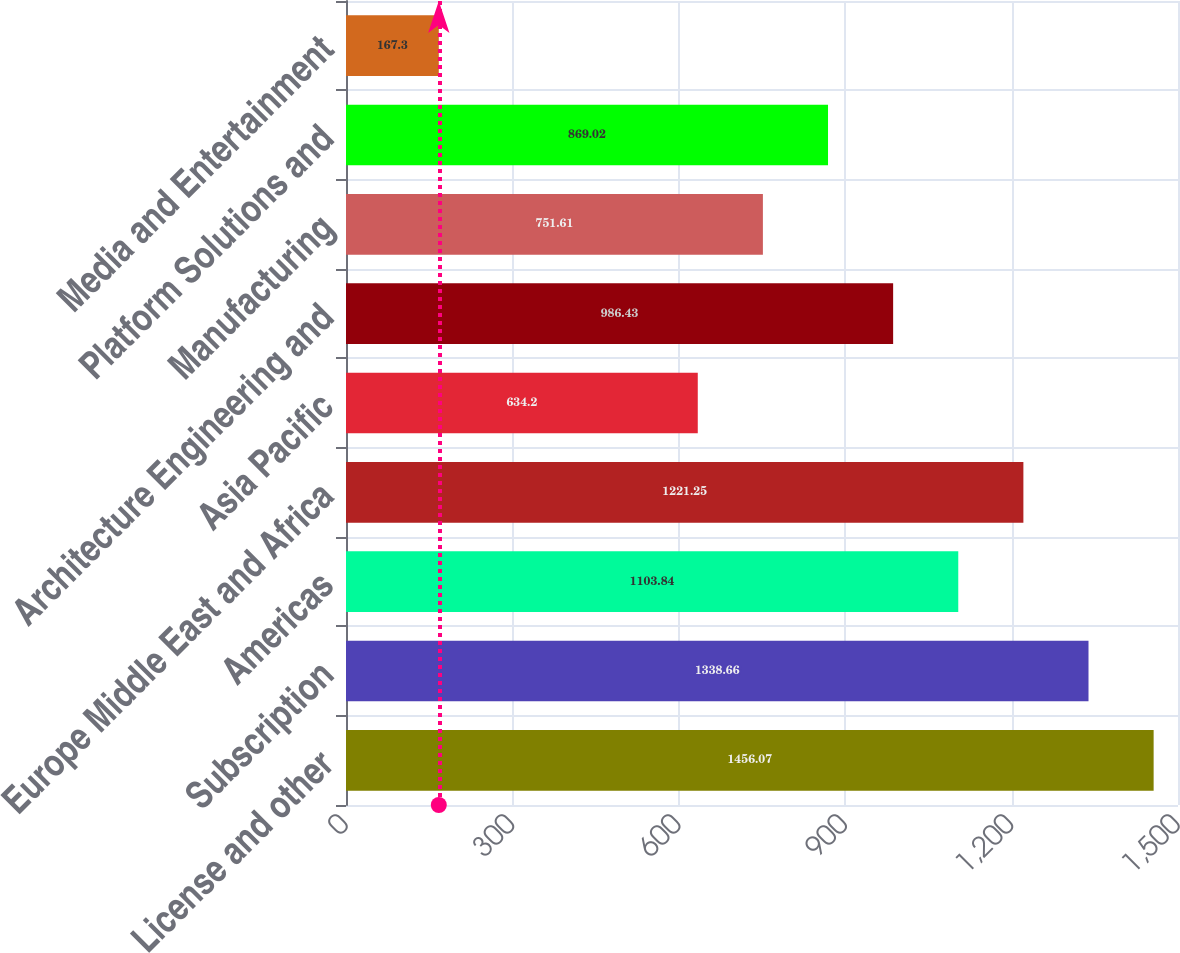Convert chart. <chart><loc_0><loc_0><loc_500><loc_500><bar_chart><fcel>License and other<fcel>Subscription<fcel>Americas<fcel>Europe Middle East and Africa<fcel>Asia Pacific<fcel>Architecture Engineering and<fcel>Manufacturing<fcel>Platform Solutions and<fcel>Media and Entertainment<nl><fcel>1456.07<fcel>1338.66<fcel>1103.84<fcel>1221.25<fcel>634.2<fcel>986.43<fcel>751.61<fcel>869.02<fcel>167.3<nl></chart> 